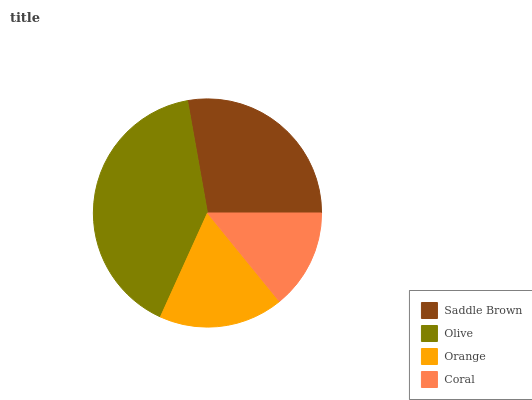Is Coral the minimum?
Answer yes or no. Yes. Is Olive the maximum?
Answer yes or no. Yes. Is Orange the minimum?
Answer yes or no. No. Is Orange the maximum?
Answer yes or no. No. Is Olive greater than Orange?
Answer yes or no. Yes. Is Orange less than Olive?
Answer yes or no. Yes. Is Orange greater than Olive?
Answer yes or no. No. Is Olive less than Orange?
Answer yes or no. No. Is Saddle Brown the high median?
Answer yes or no. Yes. Is Orange the low median?
Answer yes or no. Yes. Is Orange the high median?
Answer yes or no. No. Is Coral the low median?
Answer yes or no. No. 